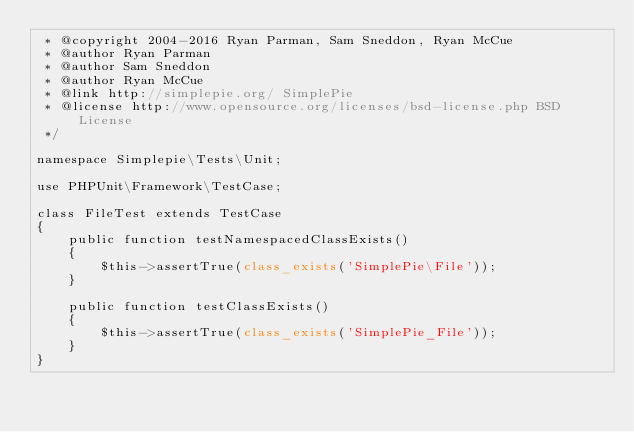Convert code to text. <code><loc_0><loc_0><loc_500><loc_500><_PHP_> * @copyright 2004-2016 Ryan Parman, Sam Sneddon, Ryan McCue
 * @author Ryan Parman
 * @author Sam Sneddon
 * @author Ryan McCue
 * @link http://simplepie.org/ SimplePie
 * @license http://www.opensource.org/licenses/bsd-license.php BSD License
 */

namespace Simplepie\Tests\Unit;

use PHPUnit\Framework\TestCase;

class FileTest extends TestCase
{
	public function testNamespacedClassExists()
	{
		$this->assertTrue(class_exists('SimplePie\File'));
	}

	public function testClassExists()
	{
		$this->assertTrue(class_exists('SimplePie_File'));
	}
}
</code> 